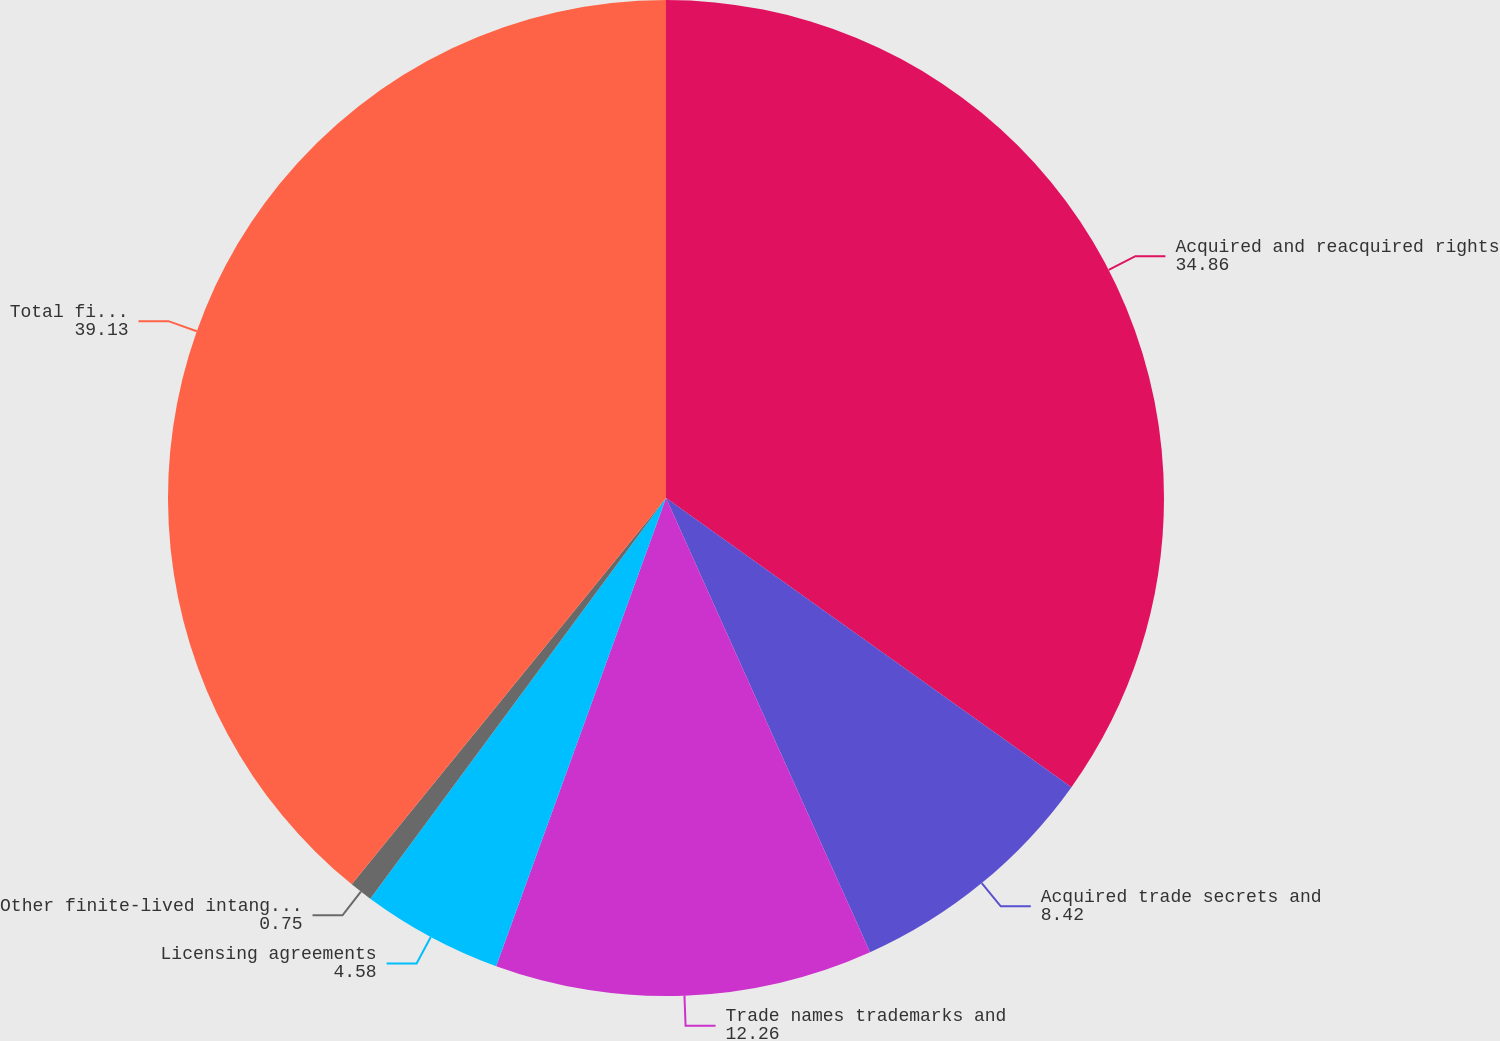Convert chart to OTSL. <chart><loc_0><loc_0><loc_500><loc_500><pie_chart><fcel>Acquired and reacquired rights<fcel>Acquired trade secrets and<fcel>Trade names trademarks and<fcel>Licensing agreements<fcel>Other finite-lived intangible<fcel>Total finite-lived intangible<nl><fcel>34.86%<fcel>8.42%<fcel>12.26%<fcel>4.58%<fcel>0.75%<fcel>39.13%<nl></chart> 